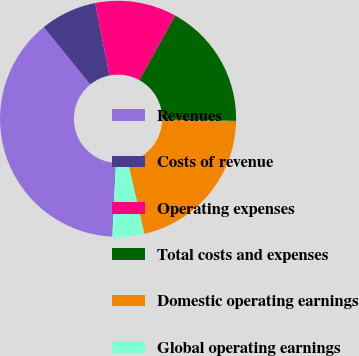Convert chart. <chart><loc_0><loc_0><loc_500><loc_500><pie_chart><fcel>Revenues<fcel>Costs of revenue<fcel>Operating expenses<fcel>Total costs and expenses<fcel>Domestic operating earnings<fcel>Global operating earnings<nl><fcel>38.39%<fcel>7.74%<fcel>11.15%<fcel>17.24%<fcel>21.15%<fcel>4.34%<nl></chart> 